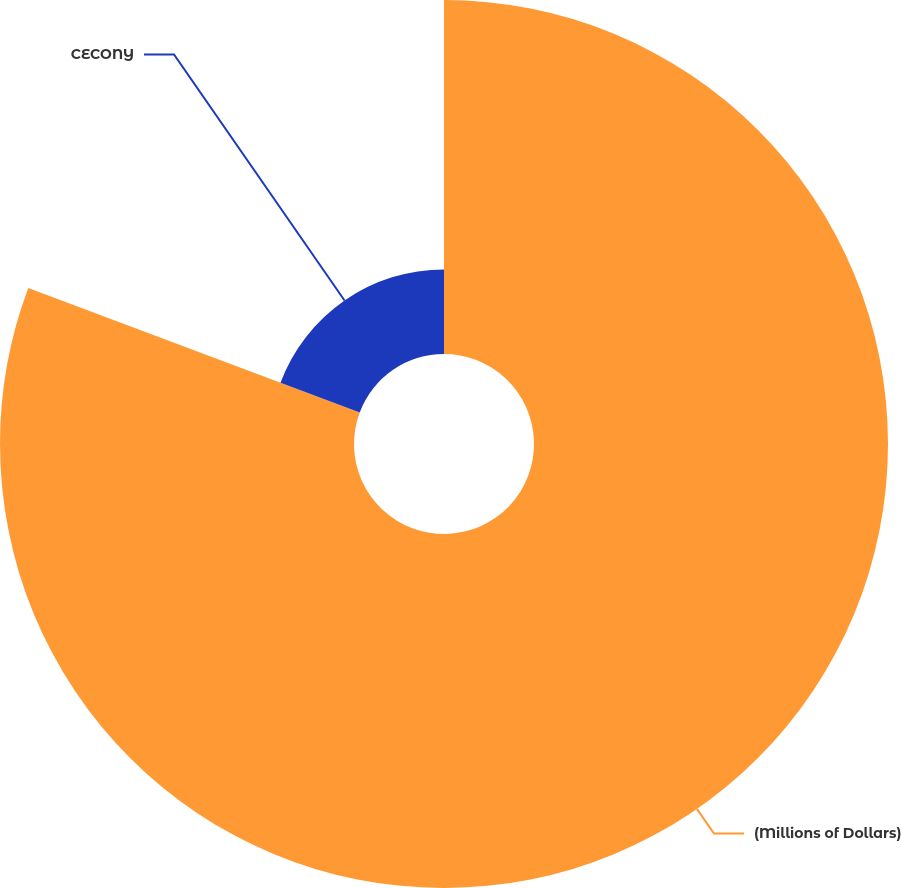Convert chart. <chart><loc_0><loc_0><loc_500><loc_500><pie_chart><fcel>(Millions of Dollars)<fcel>CECONY<nl><fcel>80.71%<fcel>19.29%<nl></chart> 